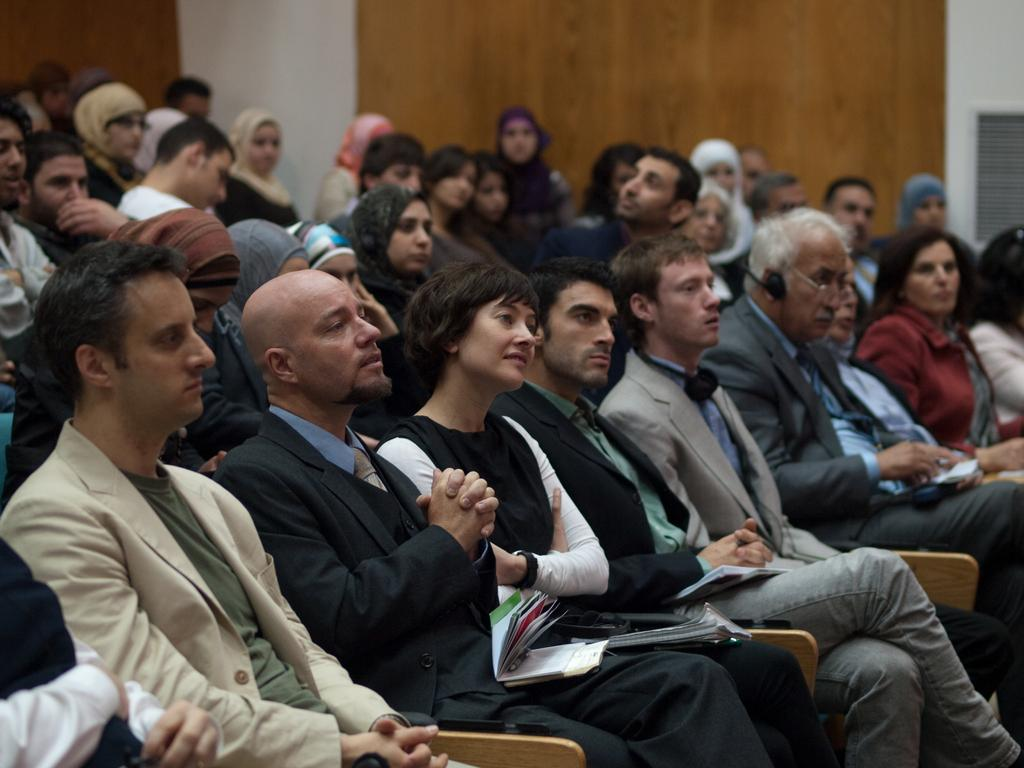Who or what can be seen in the image? There are people in the image. What are the people doing in the image? The people are sitting on chairs. What can be seen in the background of the image? There is a wall in the background of the image. What type of lift is being used by the minister in the image? There is no minister or lift present in the image. Who is the creator of the chairs in the image? The creator of the chairs is not mentioned or visible in the image. 